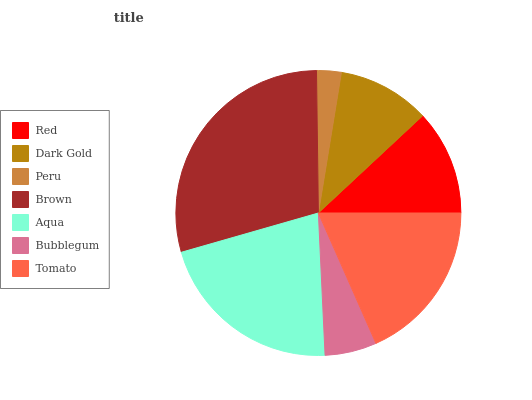Is Peru the minimum?
Answer yes or no. Yes. Is Brown the maximum?
Answer yes or no. Yes. Is Dark Gold the minimum?
Answer yes or no. No. Is Dark Gold the maximum?
Answer yes or no. No. Is Red greater than Dark Gold?
Answer yes or no. Yes. Is Dark Gold less than Red?
Answer yes or no. Yes. Is Dark Gold greater than Red?
Answer yes or no. No. Is Red less than Dark Gold?
Answer yes or no. No. Is Red the high median?
Answer yes or no. Yes. Is Red the low median?
Answer yes or no. Yes. Is Aqua the high median?
Answer yes or no. No. Is Brown the low median?
Answer yes or no. No. 